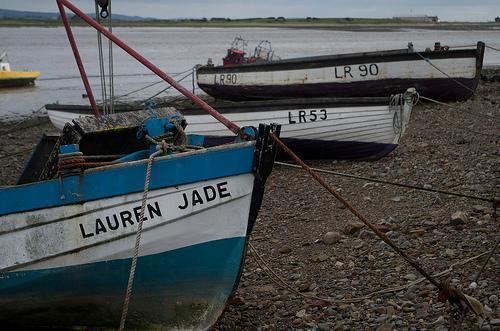How many LR's are visible?
Give a very brief answer. 3. 